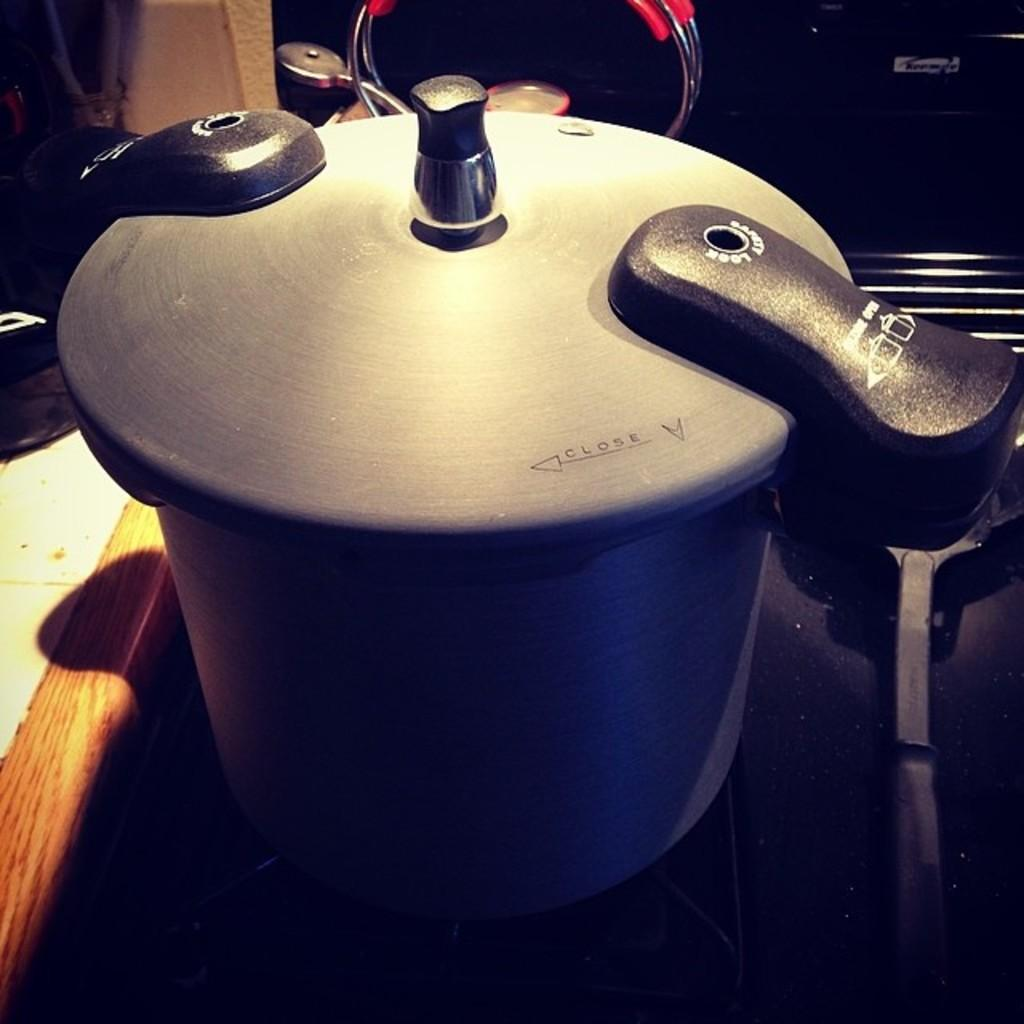<image>
Share a concise interpretation of the image provided. A kitchen appliance with an arrow showing which way the lid should be closed. 